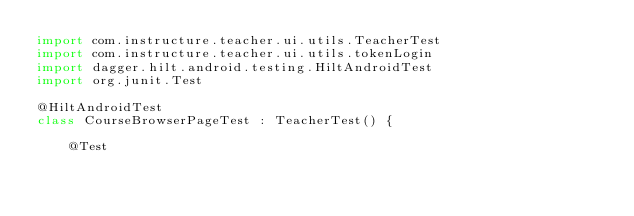<code> <loc_0><loc_0><loc_500><loc_500><_Kotlin_>import com.instructure.teacher.ui.utils.TeacherTest
import com.instructure.teacher.ui.utils.tokenLogin
import dagger.hilt.android.testing.HiltAndroidTest
import org.junit.Test

@HiltAndroidTest
class CourseBrowserPageTest : TeacherTest() {

    @Test</code> 